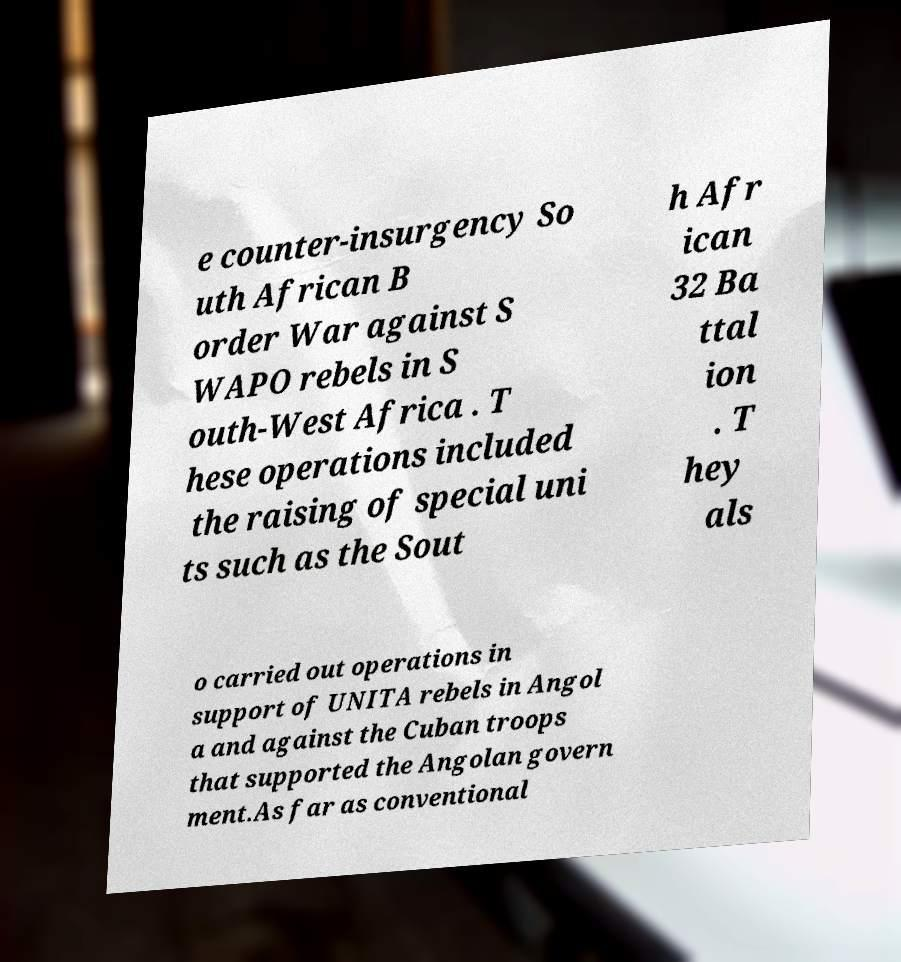Could you assist in decoding the text presented in this image and type it out clearly? e counter-insurgency So uth African B order War against S WAPO rebels in S outh-West Africa . T hese operations included the raising of special uni ts such as the Sout h Afr ican 32 Ba ttal ion . T hey als o carried out operations in support of UNITA rebels in Angol a and against the Cuban troops that supported the Angolan govern ment.As far as conventional 